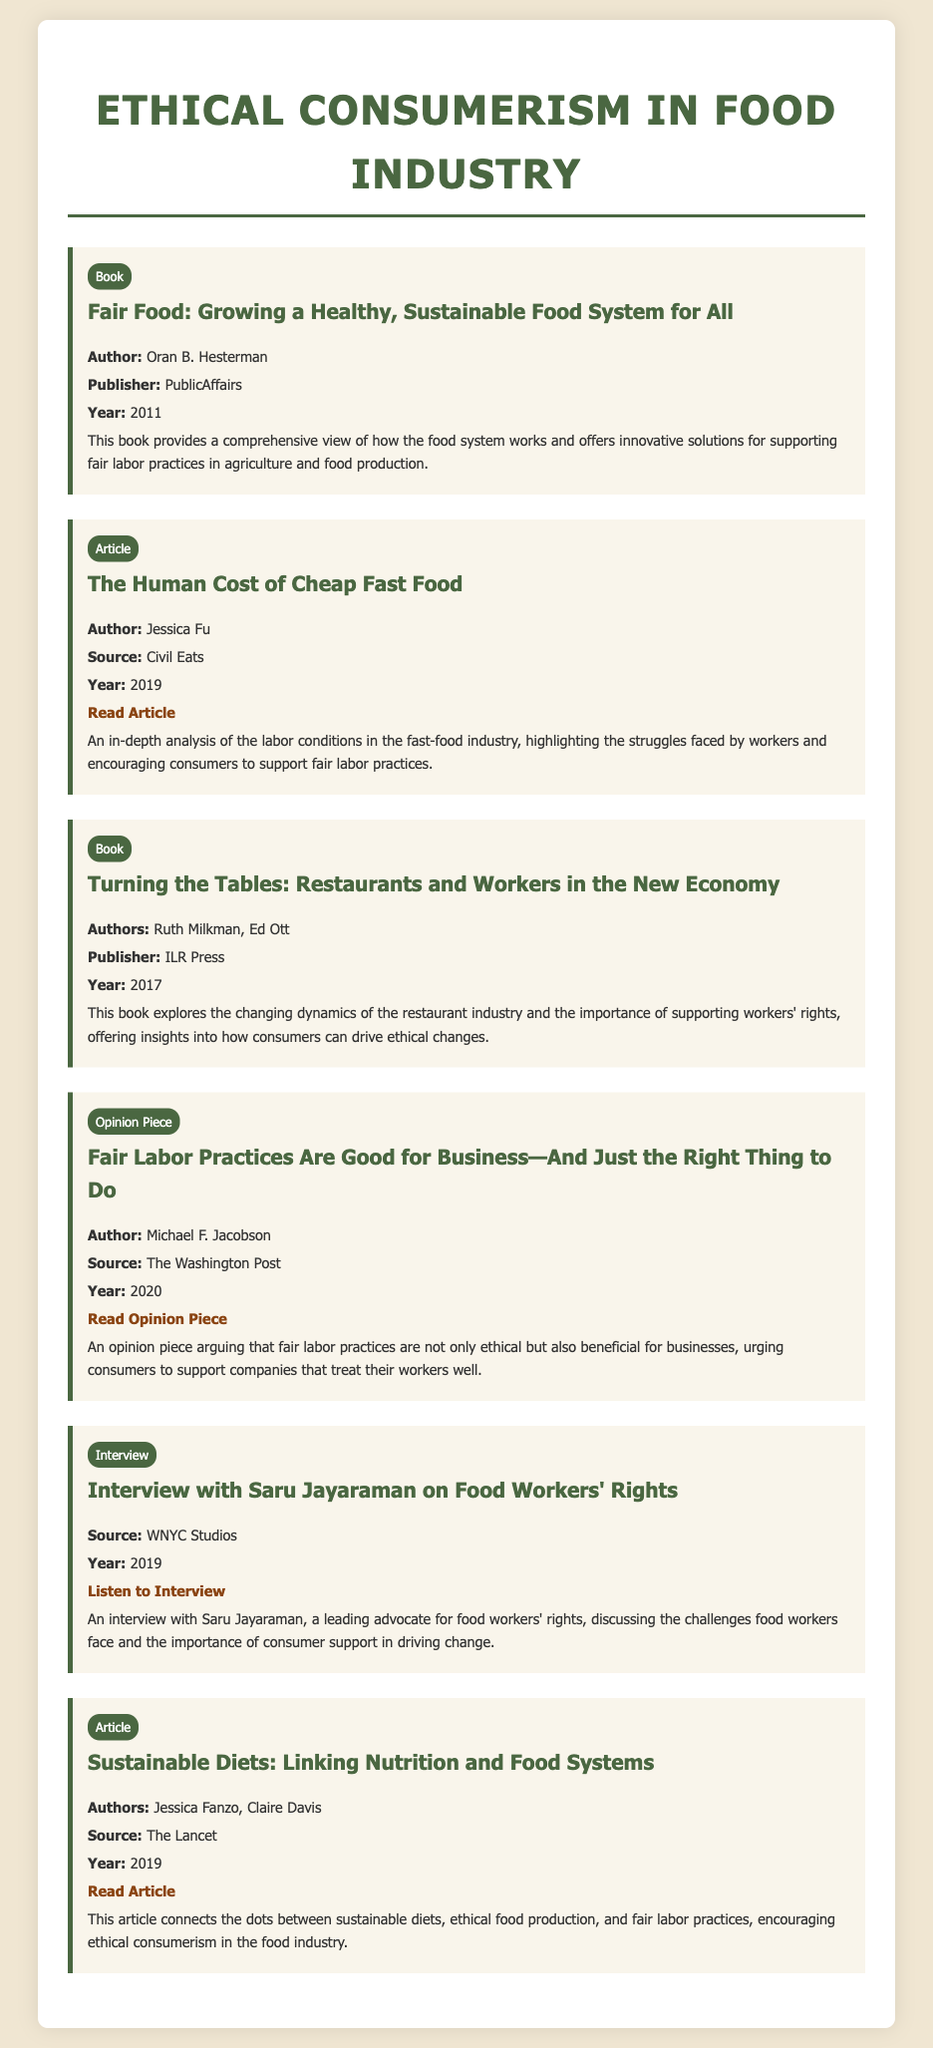What is the title of the book by Oran B. Hesterman? The title is mentioned in the document in the bibliographic entry for Oran B. Hesterman's book.
Answer: Fair Food: Growing a Healthy, Sustainable Food System for All Who is the author of the article "The Human Cost of Cheap Fast Food"? The author is specified in the bibliographic entry for that article.
Answer: Jessica Fu What year was "Turning the Tables: Restaurants and Workers in the New Economy" published? The publication year is explicitly stated in the entry for this book.
Answer: 2017 What type of document is "Fair Labor Practices Are Good for Business—And Just the Right Thing to Do"? The type of the document is identified as an opinion piece in the bibliography.
Answer: Opinion Piece What source published the interview with Saru Jayaraman? The source for the interview is mentioned in the bibliographic entry for that interview.
Answer: WNYC Studios What are the authors of the article "Sustainable Diets: Linking Nutrition and Food Systems"? This information is found in the entry related to that article.
Answer: Jessica Fanzo, Claire Davis How many book entries are included in the document? The count of book entries can be determined by reviewing each individual bibliographic entry for its type.
Answer: 2 What is the main theme of the document? The main theme is summarized across different entries that support ethical consumerism and fair labor initiatives.
Answer: Ethical consumerism and fair labor practices 